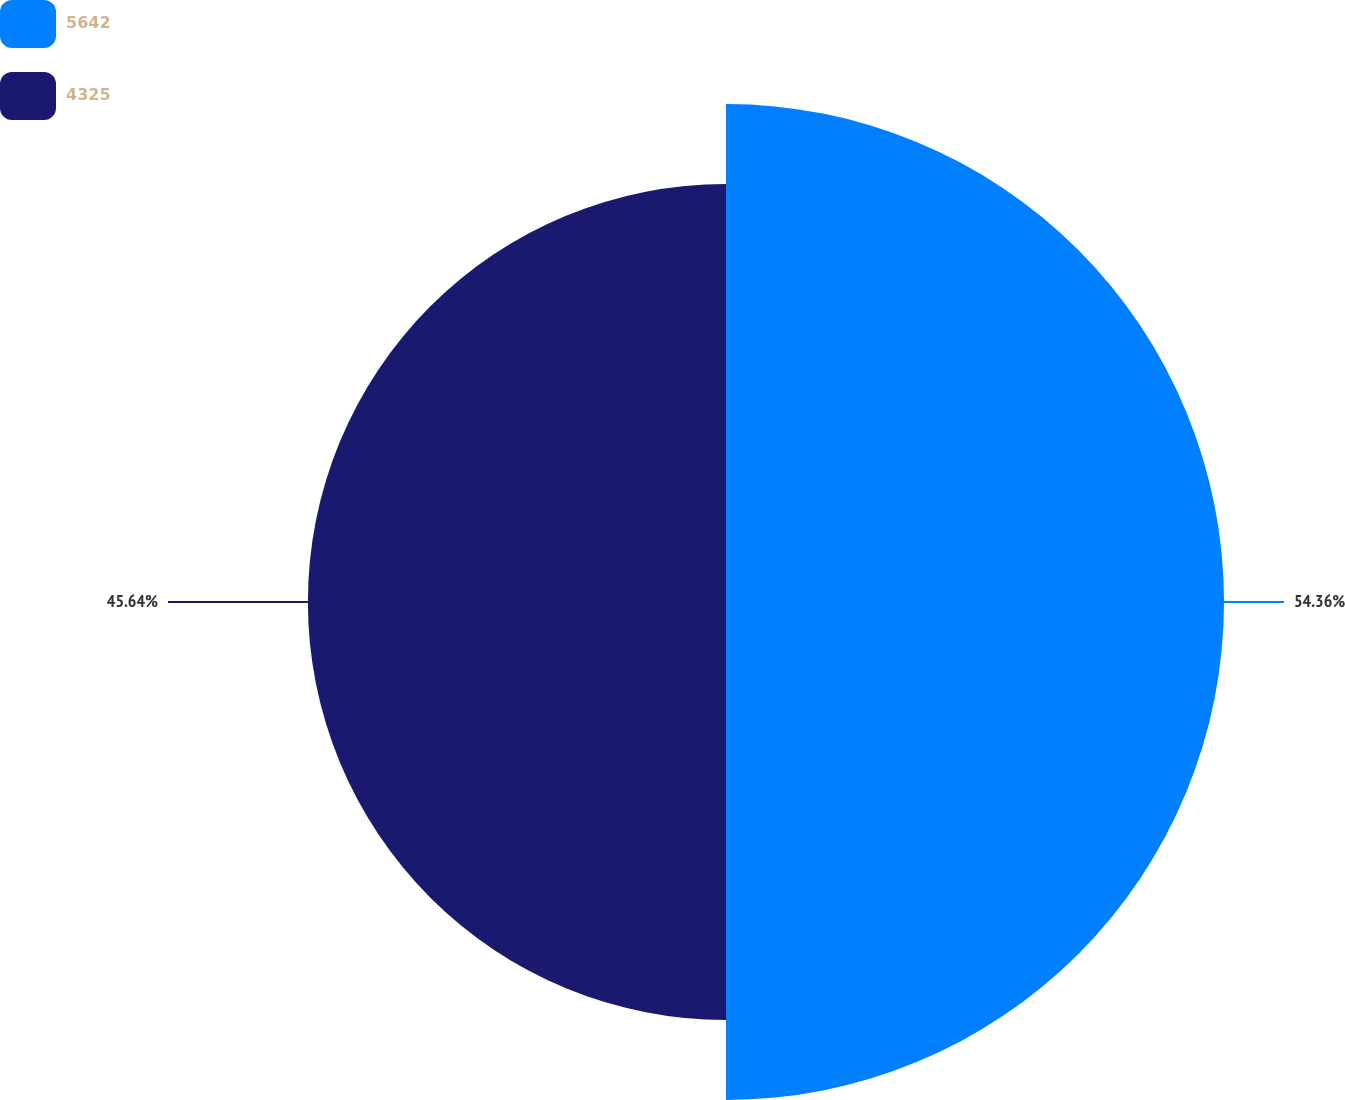Convert chart to OTSL. <chart><loc_0><loc_0><loc_500><loc_500><pie_chart><fcel>5642<fcel>4325<nl><fcel>54.36%<fcel>45.64%<nl></chart> 